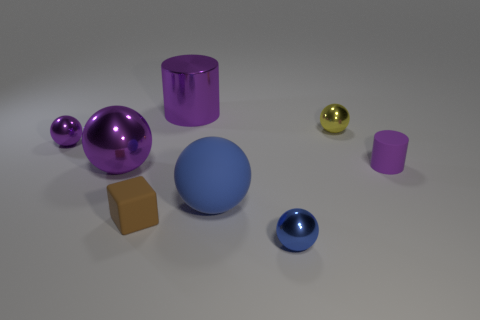There is a purple metal object left of the big ball that is on the left side of the purple metal cylinder; what size is it?
Offer a terse response. Small. There is a small blue thing that is the same shape as the tiny yellow metal object; what is it made of?
Your answer should be compact. Metal. What number of purple metallic cylinders have the same size as the purple rubber thing?
Provide a succinct answer. 0. Do the matte block and the yellow metallic thing have the same size?
Your answer should be compact. Yes. How big is the metallic sphere that is both behind the tiny matte block and right of the cube?
Your answer should be very brief. Small. Are there more large metal cylinders in front of the small purple metallic ball than tiny purple things that are to the right of the matte ball?
Make the answer very short. No. There is another matte object that is the same shape as the yellow thing; what color is it?
Your answer should be very brief. Blue. There is a large metallic thing that is to the left of the large cylinder; is it the same color as the big metal cylinder?
Offer a very short reply. Yes. What number of big brown metallic blocks are there?
Provide a short and direct response. 0. Are the purple sphere in front of the small purple sphere and the tiny brown cube made of the same material?
Offer a very short reply. No. 